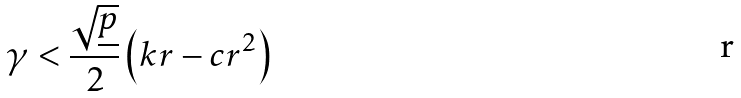<formula> <loc_0><loc_0><loc_500><loc_500>\gamma < \frac { \sqrt { \underline { p } } } { 2 } \left ( { k r } - c r ^ { 2 } \right )</formula> 